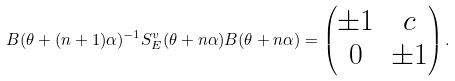Convert formula to latex. <formula><loc_0><loc_0><loc_500><loc_500>B ( \theta + ( n + 1 ) \alpha ) ^ { - 1 } S _ { E } ^ { v } ( \theta + n \alpha ) B ( \theta + n \alpha ) = \begin{pmatrix} \pm 1 & c \\ 0 & \pm 1 \end{pmatrix} .</formula> 